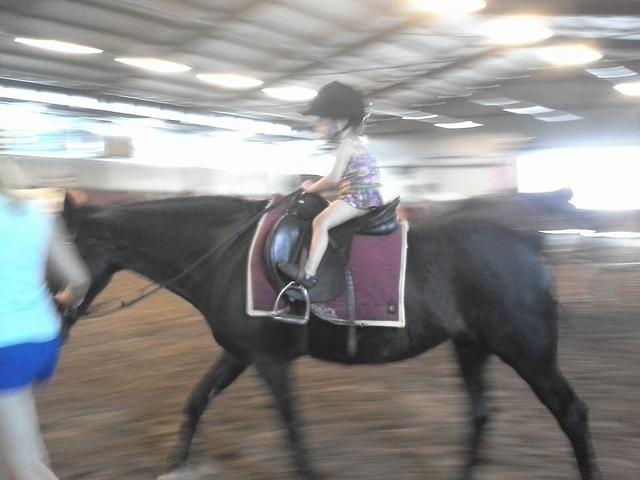Is the saddle brightly colored?
Be succinct. No. Is the little girl learning how to ride a horse?
Be succinct. Yes. What color is the horse?
Write a very short answer. Black. How many people are in this image?
Concise answer only. 2. 